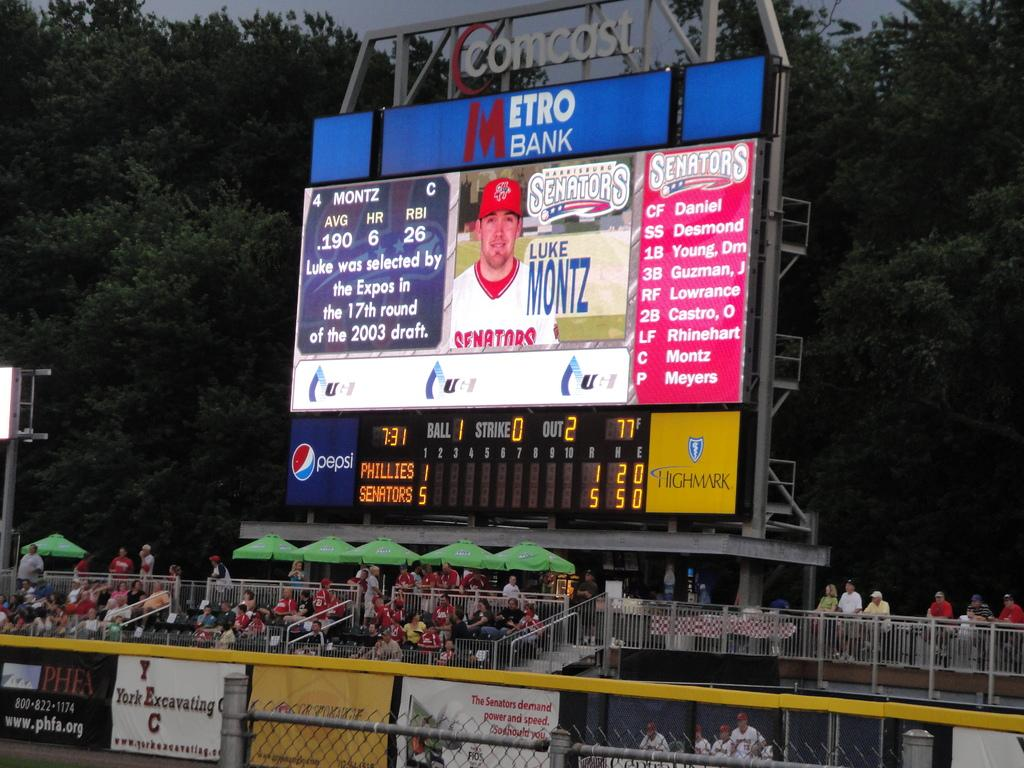Provide a one-sentence caption for the provided image. Big sign of an athletic on a metro bank banner with two teams playing baseball. 